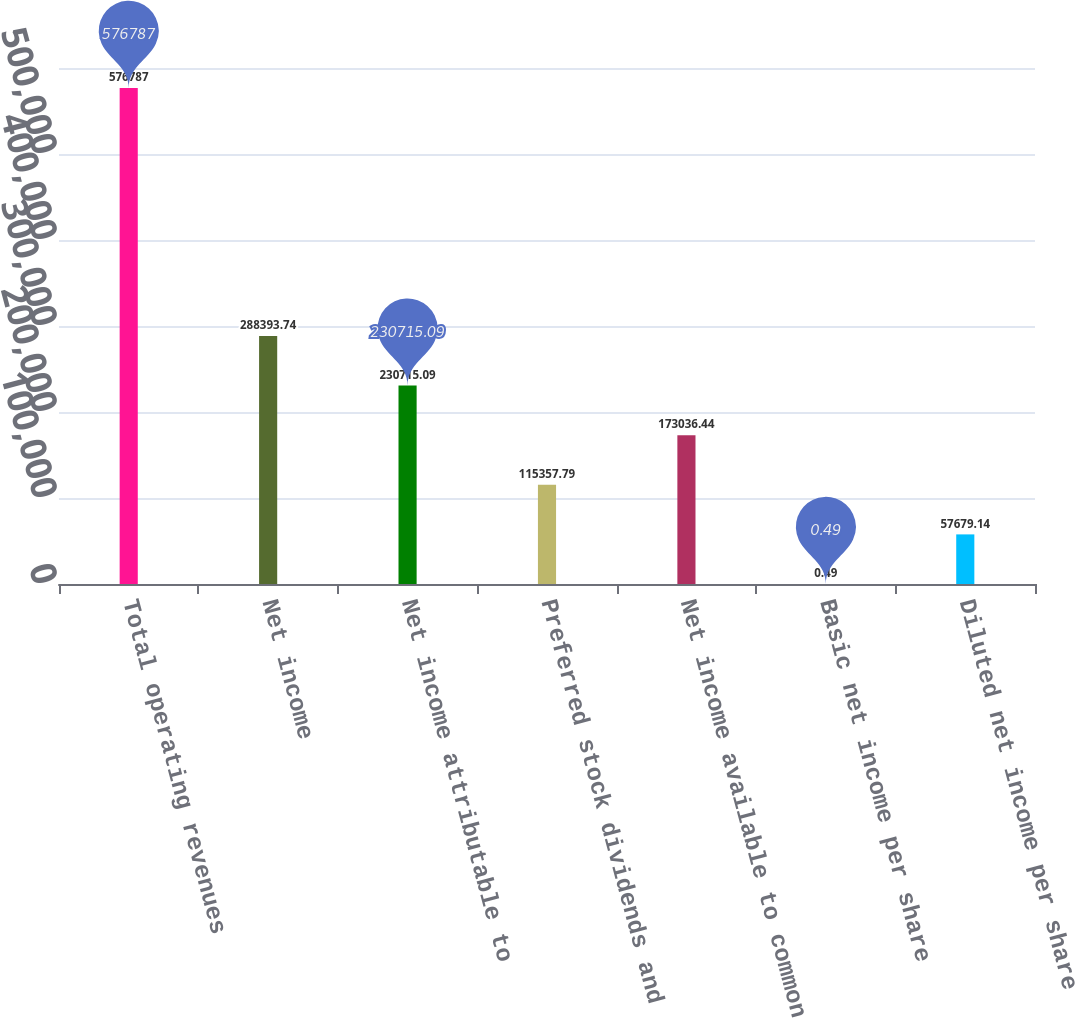<chart> <loc_0><loc_0><loc_500><loc_500><bar_chart><fcel>Total operating revenues<fcel>Net income<fcel>Net income attributable to<fcel>Preferred stock dividends and<fcel>Net income available to common<fcel>Basic net income per share<fcel>Diluted net income per share<nl><fcel>576787<fcel>288394<fcel>230715<fcel>115358<fcel>173036<fcel>0.49<fcel>57679.1<nl></chart> 